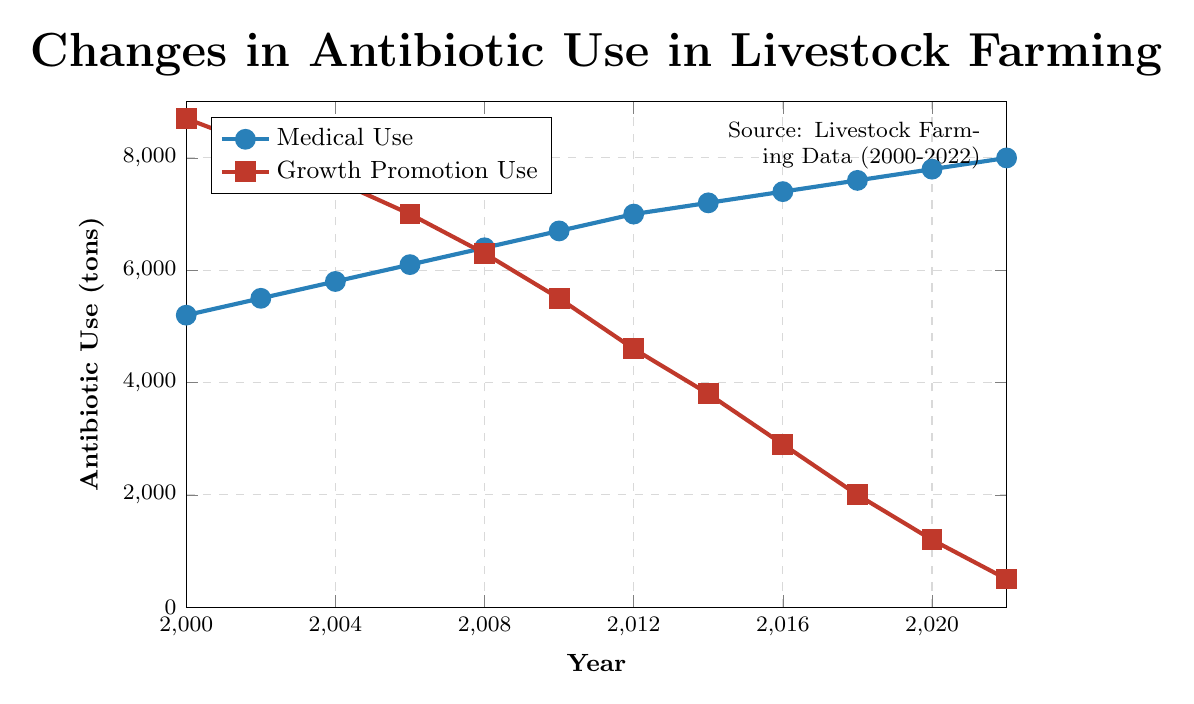What are the antibiotic use values for medical and growth promotion purposes in 2000? The chart shows two lines representing antibiotic use for medical and growth promotion purposes. In 2000, the value for medical use is at 5200 tons, and for growth promotion use, it is at 8700 tons.
Answer: Medical: 5200 tons, Growth Promotion: 8700 tons How much did antibiotic use for growth promotion purposes decrease between 2000 and 2022? To find the decrease, subtract the value in 2022 from the value in 2000 for growth promotion use. In 2000, the value is 8700 tons, and in 2022, it is 500 tons (8700 - 500 = 8200 tons).
Answer: 8200 tons Which year shows the highest antibiotic use for medical purposes? By looking at the lines and the labels, the final year, 2022, shows the highest value for medical use, which is at 8000 tons.
Answer: 2022 In which year did antibiotic use for growth promotion drop below 3000 tons? The chart shows that in 2016, the antibiotic use for growth promotion dropped to 2900 tons, which is the first value below 3000 tons.
Answer: 2016 What is the percentage reduction in growth promotion use from 2014 to 2022? Calculate the percentage reduction by finding the difference between the two years and then dividing by the initial value (in 2014). The values are 3800 tons in 2014 and 500 tons in 2022. The reduction is 3800 - 500 = 3300 tons. The percentage reduction is (3300 / 3800) * 100 = 86.84%.
Answer: 86.84% Compare the trend in antibiotic use for medical purposes to growth promotion purposes between 2000 and 2022. From the chart, the antibiotic use for medical purposes shows a consistent increase from 5200 tons in 2000 to 8000 tons in 2022. In contrast, the use for growth promotion purposes shows a significant decrease from 8700 tons in 2000 to 500 tons in 2022. This indicates a diverging trend where medical use is rising, while growth promotion use is declining.
Answer: Medical: Increasing, Growth Promotion: Decreasing In which year did the antibiotic use for medical purposes first surpass 6000 tons? The chart indicates that in 2006, the antibiotic use for medical purposes is at 6100 tons, which is the first time it surpasses 6000 tons.
Answer: 2006 What is the total antibiotic use for medical and growth promotion purposes combined in 2010? Add the values for medical and growth promotion uses in 2010. The values are 6700 tons (medical) and 5500 tons (growth promotion). So, 6700 + 5500 = 12200 tons.
Answer: 12200 tons Between 2018 and 2022, what is the average annual decrease in antibiotic use for growth promotion purposes? Calculate the annual decrease over the 4-year period. The values are 2000 tons in 2018 and 500 tons in 2022. The total decrease is 2000 - 500 = 1500 tons. The average annual decrease is 1500 / 4 = 375 tons.
Answer: 375 tons 